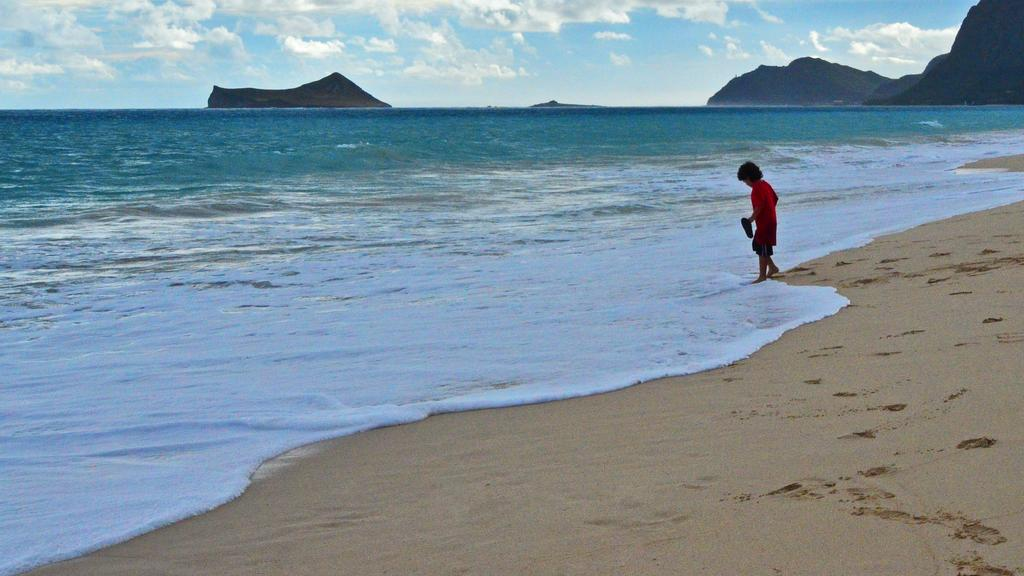What is the main subject of the image? There is a boy in the image. What is the boy holding in his hand? The boy is holding an object in his hand. What type of surface is the boy standing on? The boy is standing on sand. What natural element can be seen in the image? Water is visible in the image. What type of geological feature is present in the image? Rocks are present in the image. What is visible in the background of the image? The sky is visible in the background of the image. What atmospheric feature can be seen in the sky? Clouds are present in the sky. Is there a birthday celebration happening in the image? There is no indication of a birthday celebration in the image. Can you see a baby in the image? There is no baby present in the image; it features a boy. 